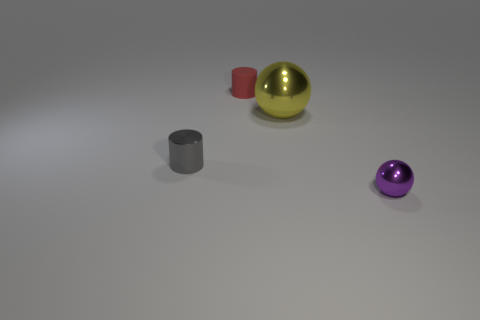There is a yellow object that is made of the same material as the tiny gray object; what is its size?
Make the answer very short. Large. Is the material of the tiny cylinder that is in front of the red rubber cylinder the same as the large yellow ball?
Ensure brevity in your answer.  Yes. Is there any other thing that has the same size as the gray cylinder?
Give a very brief answer. Yes. There is a yellow metal ball; are there any balls in front of it?
Your response must be concise. Yes. There is a tiny object that is on the left side of the small red rubber thing that is behind the small cylinder on the left side of the rubber thing; what color is it?
Provide a succinct answer. Gray. The purple object that is the same size as the red cylinder is what shape?
Keep it short and to the point. Sphere. Is the number of gray metallic objects greater than the number of small blue objects?
Your answer should be compact. Yes. Is there a red rubber object that is left of the sphere that is left of the purple metal ball?
Ensure brevity in your answer.  Yes. There is another shiny object that is the same shape as the red object; what color is it?
Your answer should be compact. Gray. There is a big sphere that is made of the same material as the small gray thing; what color is it?
Your answer should be compact. Yellow. 